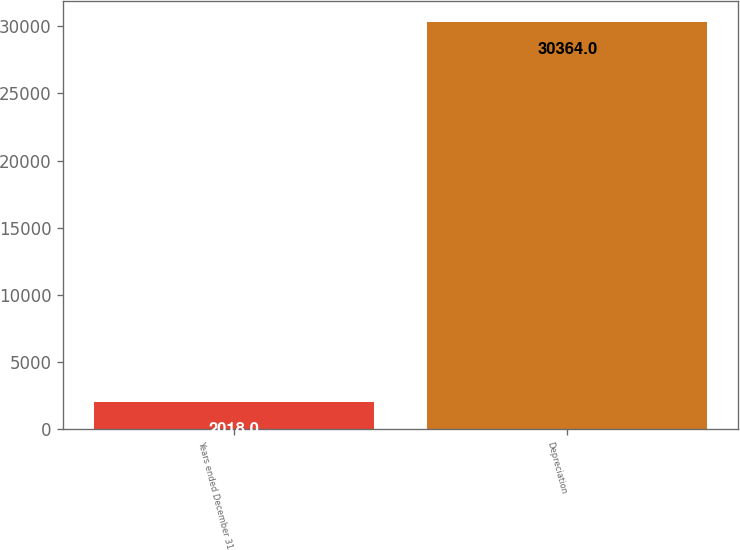Convert chart. <chart><loc_0><loc_0><loc_500><loc_500><bar_chart><fcel>Years ended December 31<fcel>Depreciation<nl><fcel>2018<fcel>30364<nl></chart> 